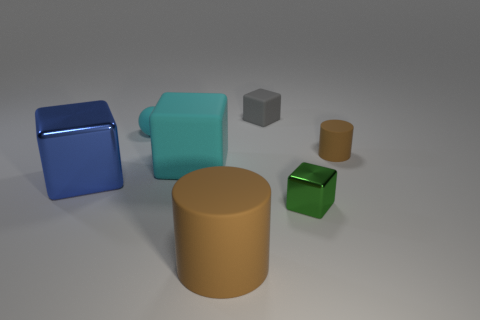Subtract all tiny gray blocks. How many blocks are left? 3 Add 1 cyan matte balls. How many objects exist? 8 Subtract all green cubes. How many cubes are left? 3 Subtract all yellow blocks. Subtract all purple cylinders. How many blocks are left? 4 Subtract all spheres. How many objects are left? 6 Add 5 small objects. How many small objects are left? 9 Add 1 spheres. How many spheres exist? 2 Subtract 0 red cylinders. How many objects are left? 7 Subtract all large brown rubber cylinders. Subtract all cyan matte objects. How many objects are left? 4 